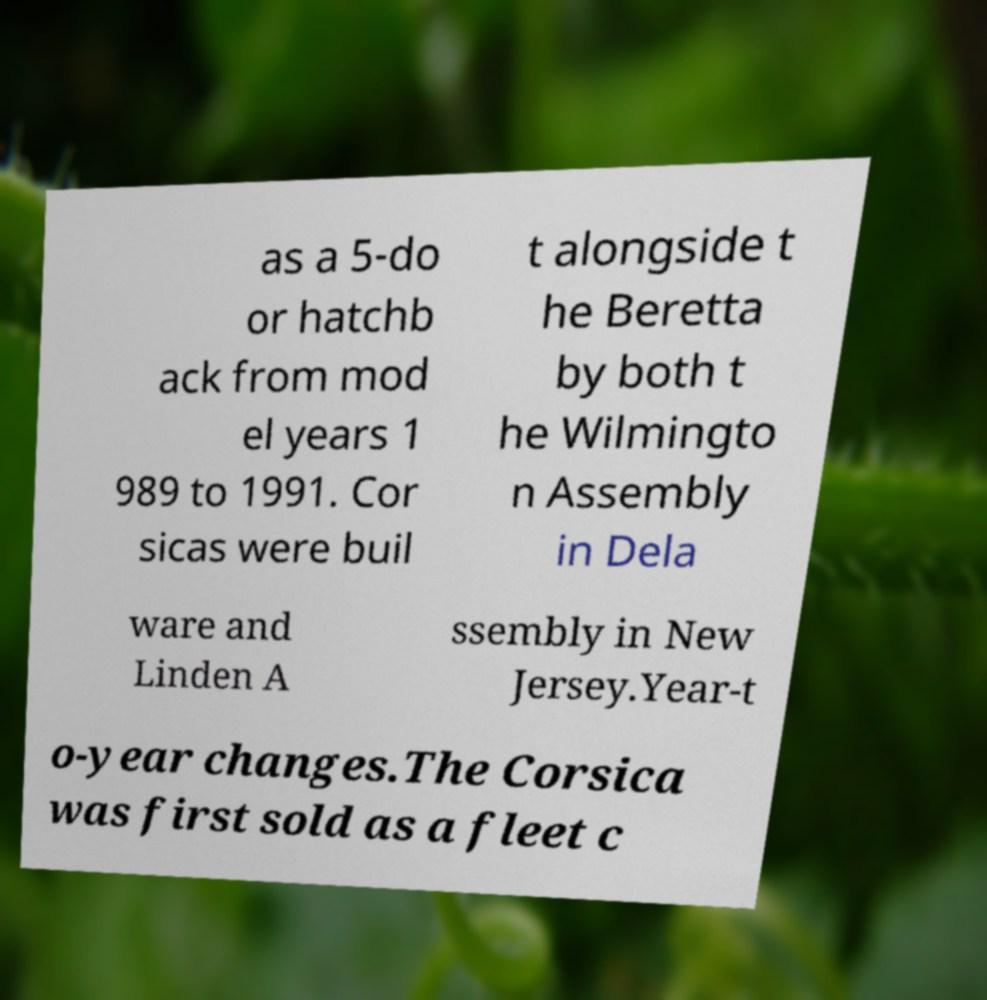I need the written content from this picture converted into text. Can you do that? as a 5-do or hatchb ack from mod el years 1 989 to 1991. Cor sicas were buil t alongside t he Beretta by both t he Wilmingto n Assembly in Dela ware and Linden A ssembly in New Jersey.Year-t o-year changes.The Corsica was first sold as a fleet c 